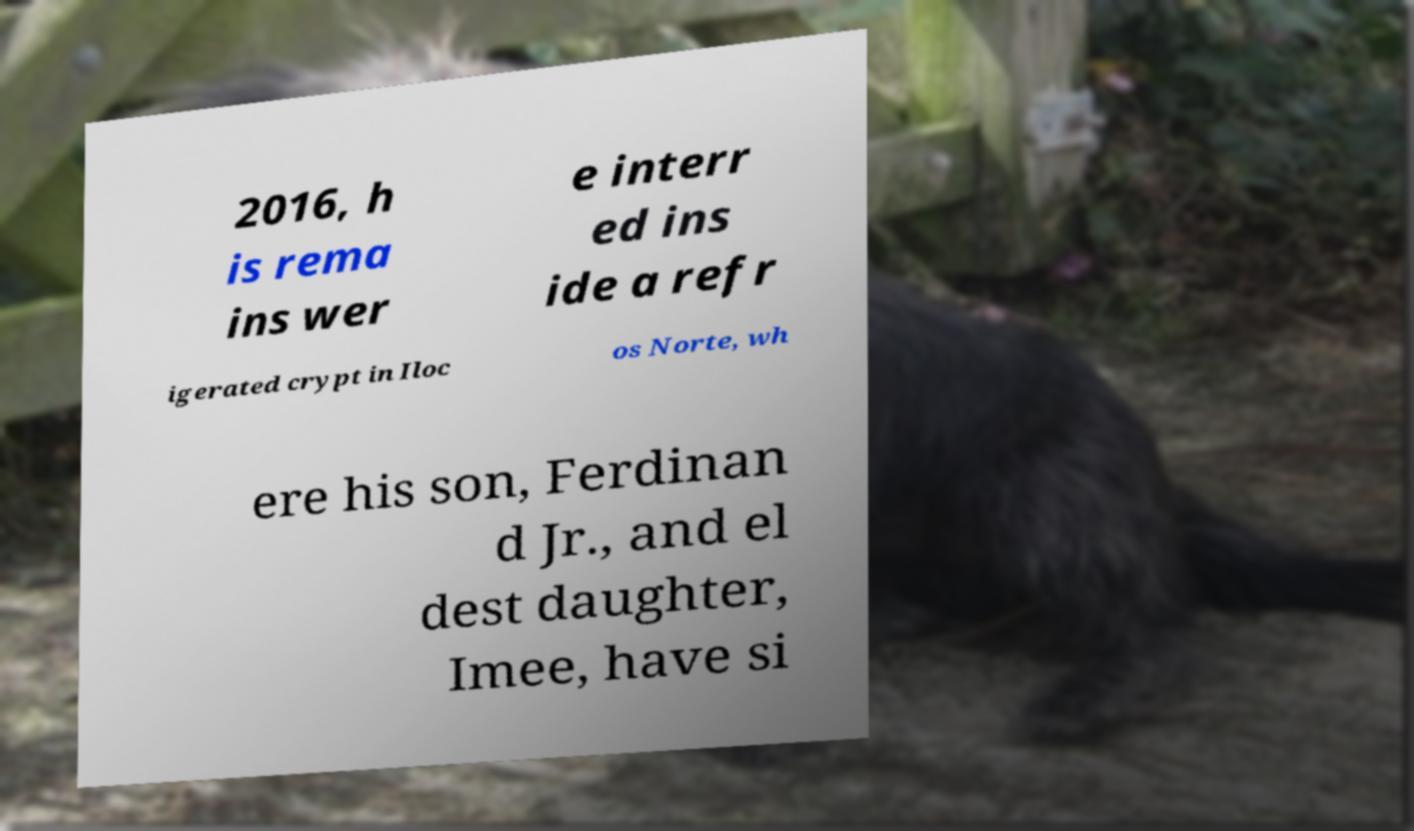Can you accurately transcribe the text from the provided image for me? 2016, h is rema ins wer e interr ed ins ide a refr igerated crypt in Iloc os Norte, wh ere his son, Ferdinan d Jr., and el dest daughter, Imee, have si 